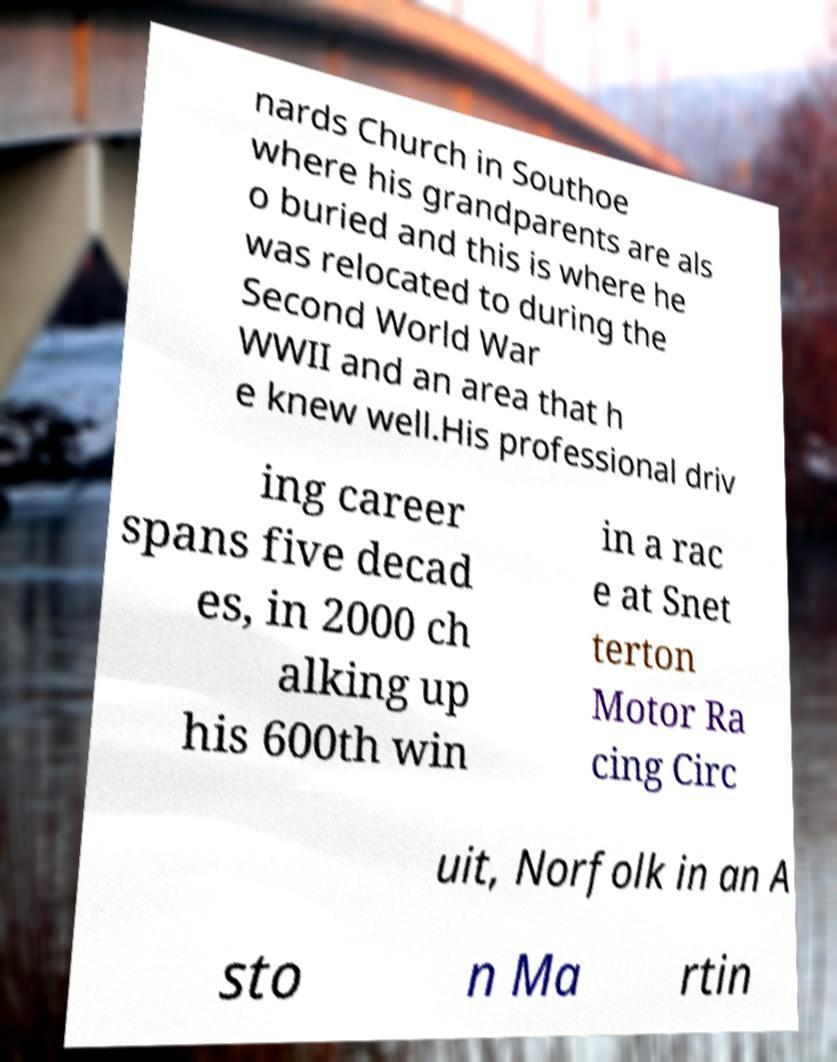I need the written content from this picture converted into text. Can you do that? nards Church in Southoe where his grandparents are als o buried and this is where he was relocated to during the Second World War WWII and an area that h e knew well.His professional driv ing career spans five decad es, in 2000 ch alking up his 600th win in a rac e at Snet terton Motor Ra cing Circ uit, Norfolk in an A sto n Ma rtin 